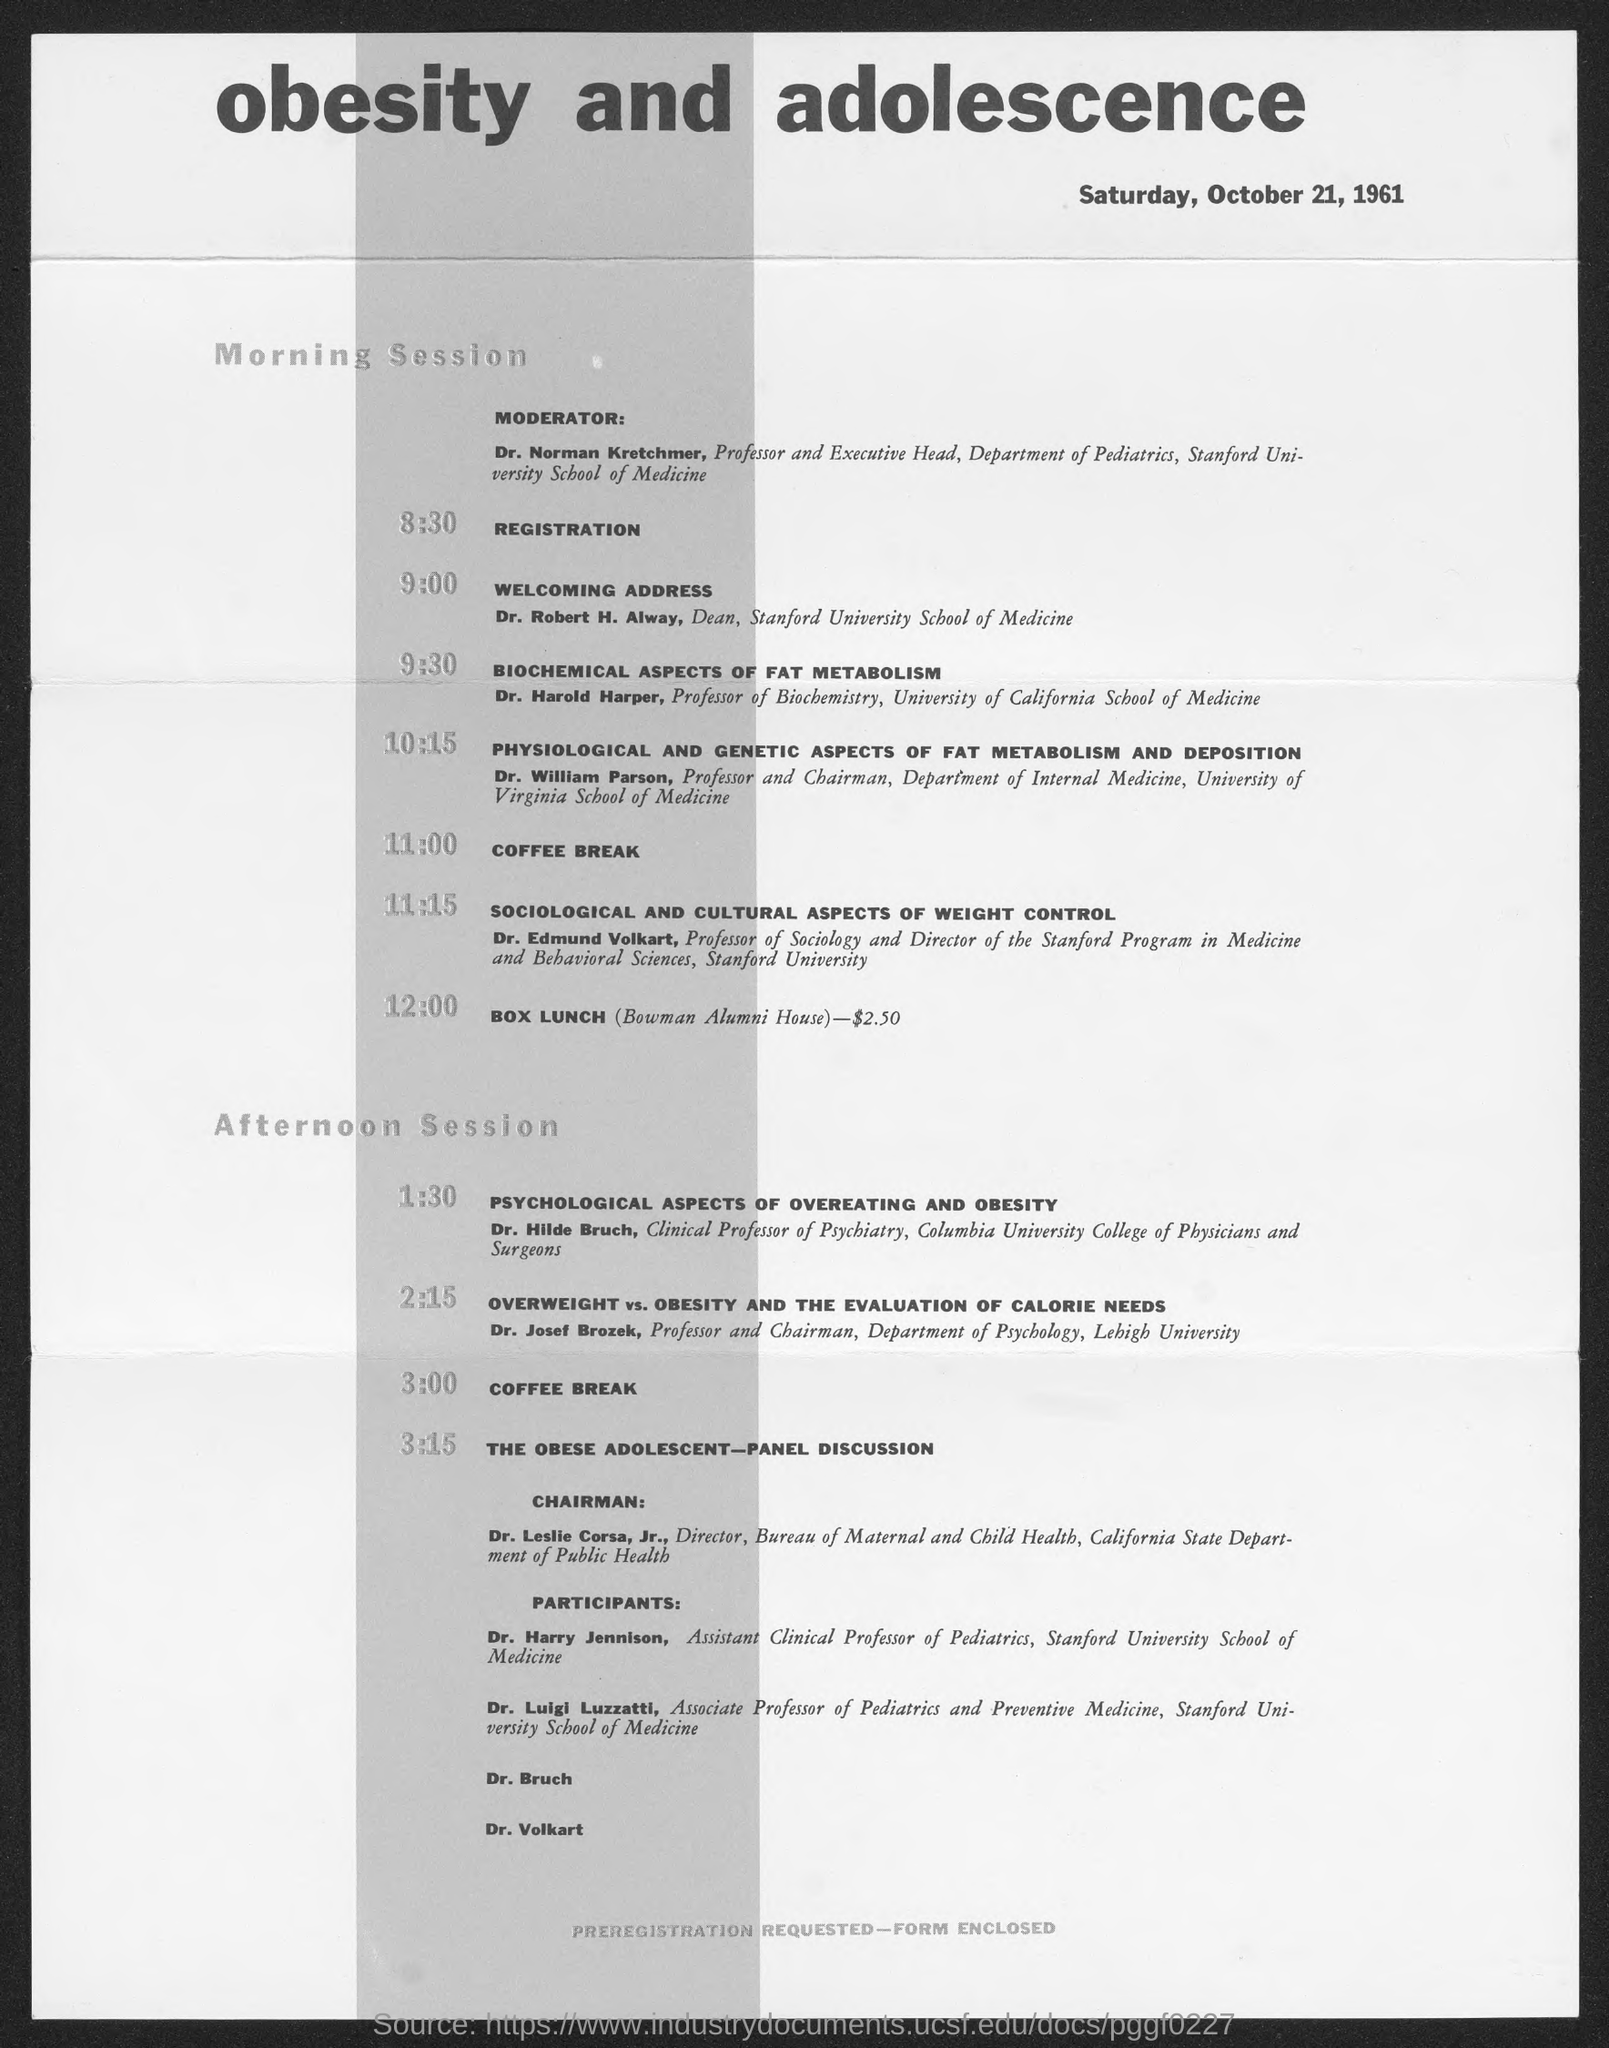Who is the Moderator for the sessions?
Provide a short and direct response. Dr. Norman Kretchmer. What time is the registration for the sessions done?
Your response must be concise. 8:30. Who is giving the welcoming address for the morning sessions?
Ensure brevity in your answer.  Dr. Robert H. Alway. What is the designation of Dr. Robert H. Alway?
Keep it short and to the point. Dean, Stanford University School of Medicine. What time is the coffee break for morning session?
Your answer should be very brief. 11:00. Who is presenting the session on ' Biochemical Aspects of Fat Metabolism'?
Provide a short and direct response. Dr. Harold Harper. Who is the chairman for 'The Obese Adolescent - Panel Discussion'?
Keep it short and to the point. Dr. Leslie Corsa, Jr.,. 